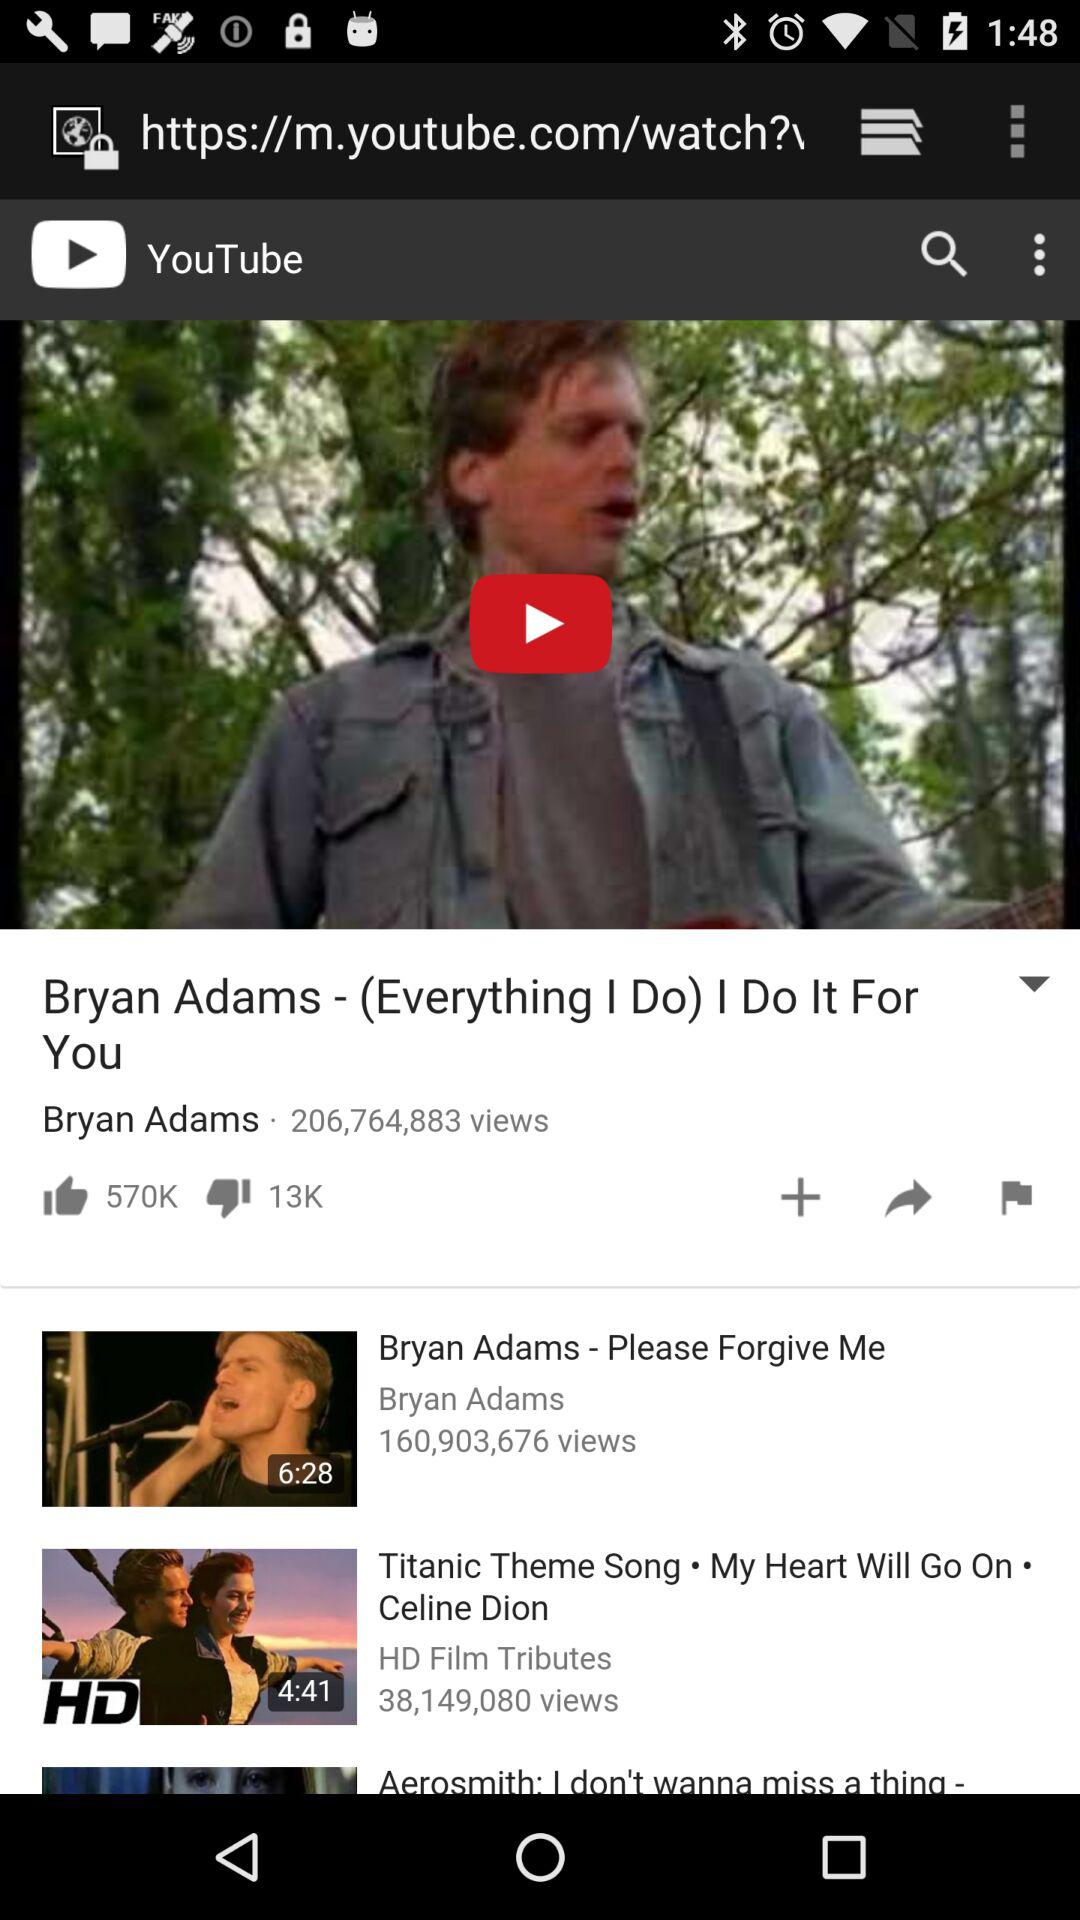How long is "Bryan Adams - Please Forgive Me"? "Bryan Adams - Please Forgive Me" is 6 minutes 28 seconds long. 